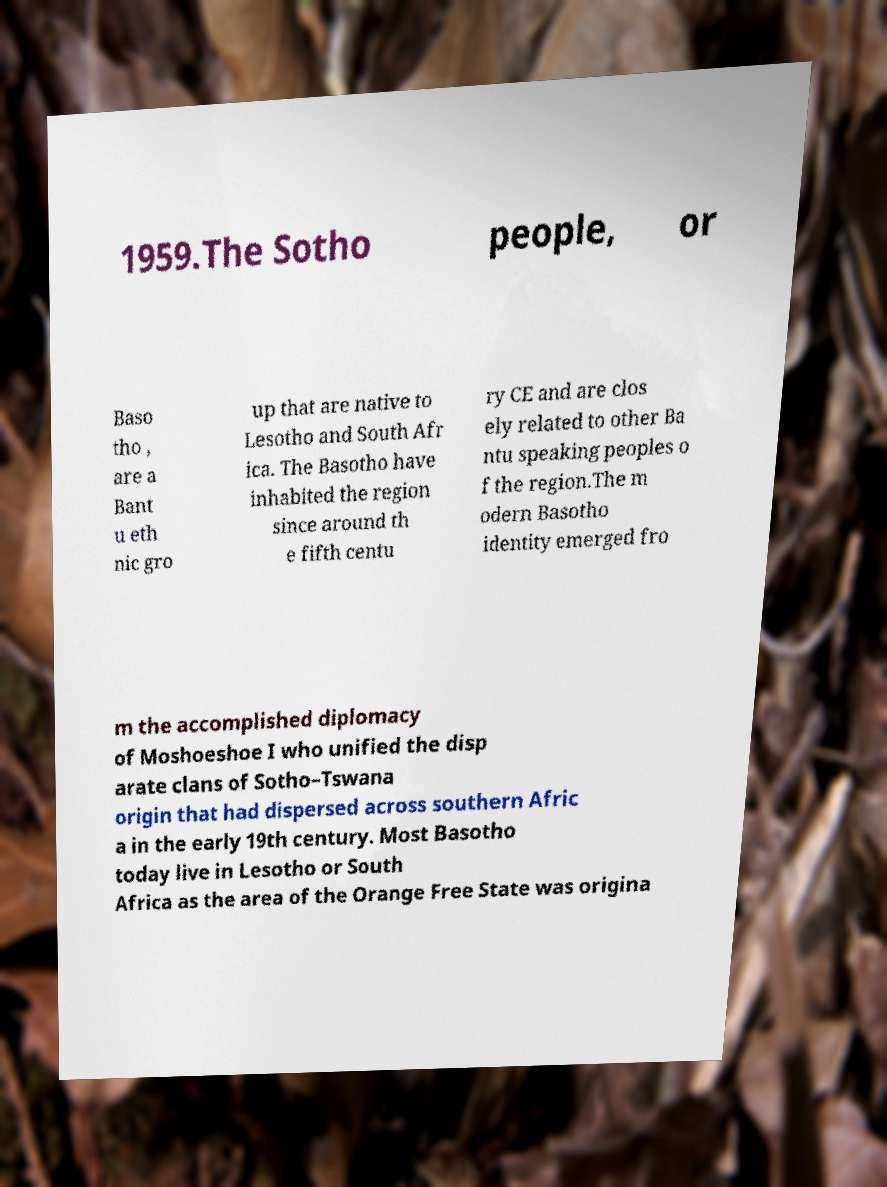Could you extract and type out the text from this image? 1959.The Sotho people, or Baso tho , are a Bant u eth nic gro up that are native to Lesotho and South Afr ica. The Basotho have inhabited the region since around th e fifth centu ry CE and are clos ely related to other Ba ntu speaking peoples o f the region.The m odern Basotho identity emerged fro m the accomplished diplomacy of Moshoeshoe I who unified the disp arate clans of Sotho–Tswana origin that had dispersed across southern Afric a in the early 19th century. Most Basotho today live in Lesotho or South Africa as the area of the Orange Free State was origina 